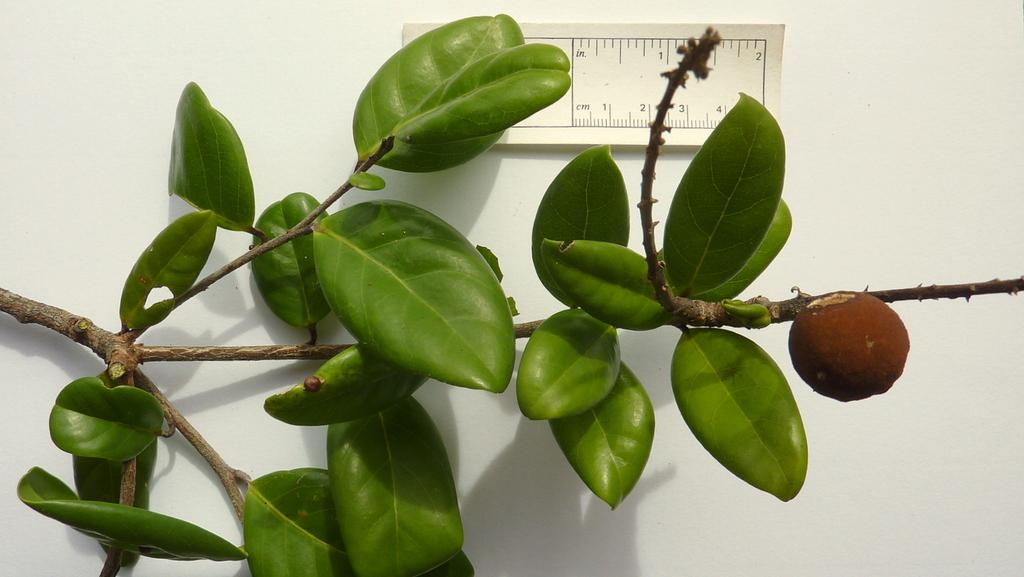What type of living organism can be seen in the image? There is a plant in the image. What is the plant producing? The plant has fruit. What can be seen in the background of the image? There is a wall in the background of the image. What is placed on the wall in the background? There is a scale placed on the wall in the background. What type of rock is being ploughed by the farmer in the image? There is no farmer or rock present in the image; it features a plant with fruit and a wall with a scale in the background. 